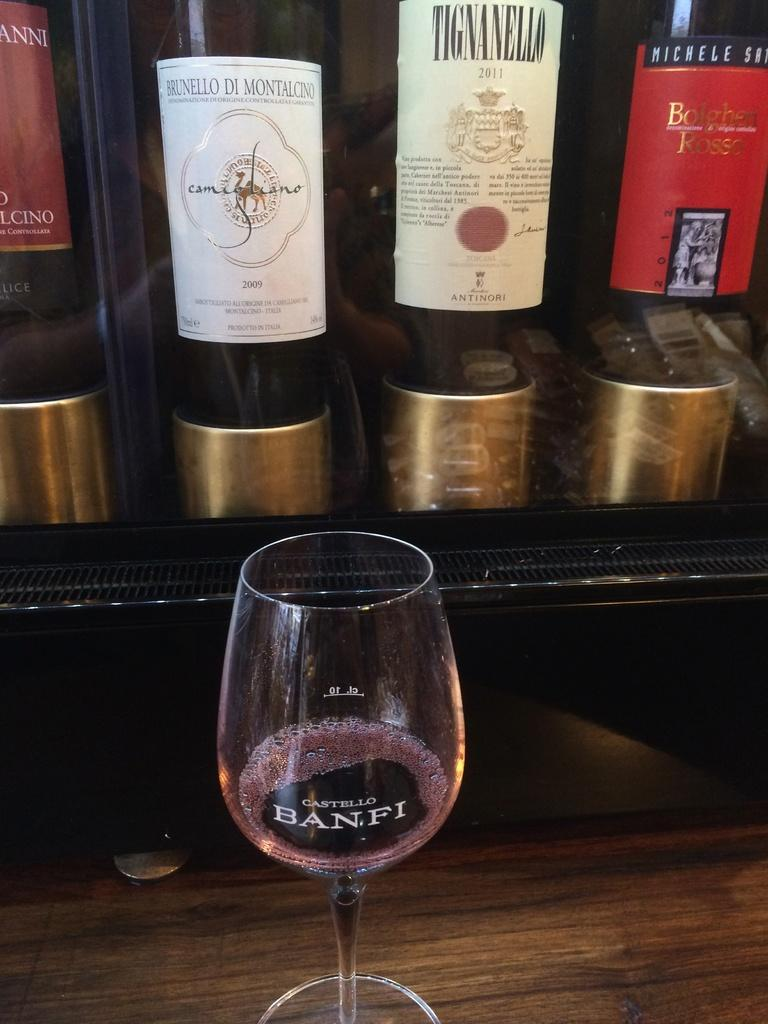<image>
Write a terse but informative summary of the picture. Castello Banfi wine glass in front of other wine bottles. 